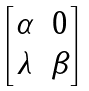Convert formula to latex. <formula><loc_0><loc_0><loc_500><loc_500>\begin{bmatrix} \alpha & 0 \\ \lambda & \beta \end{bmatrix}</formula> 